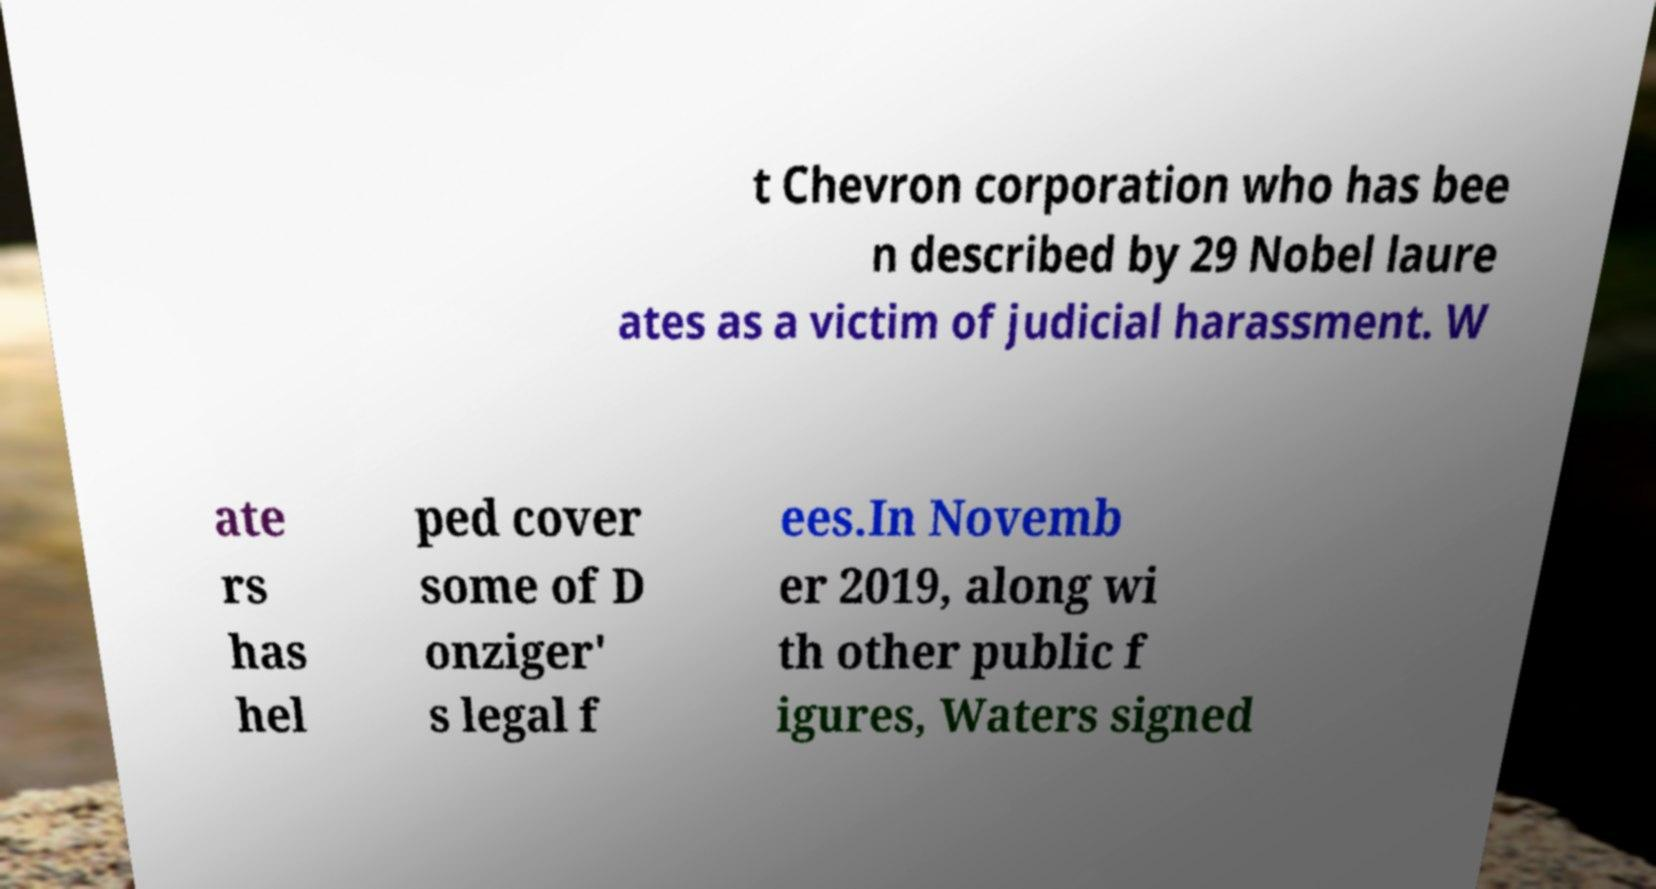I need the written content from this picture converted into text. Can you do that? t Chevron corporation who has bee n described by 29 Nobel laure ates as a victim of judicial harassment. W ate rs has hel ped cover some of D onziger' s legal f ees.In Novemb er 2019, along wi th other public f igures, Waters signed 